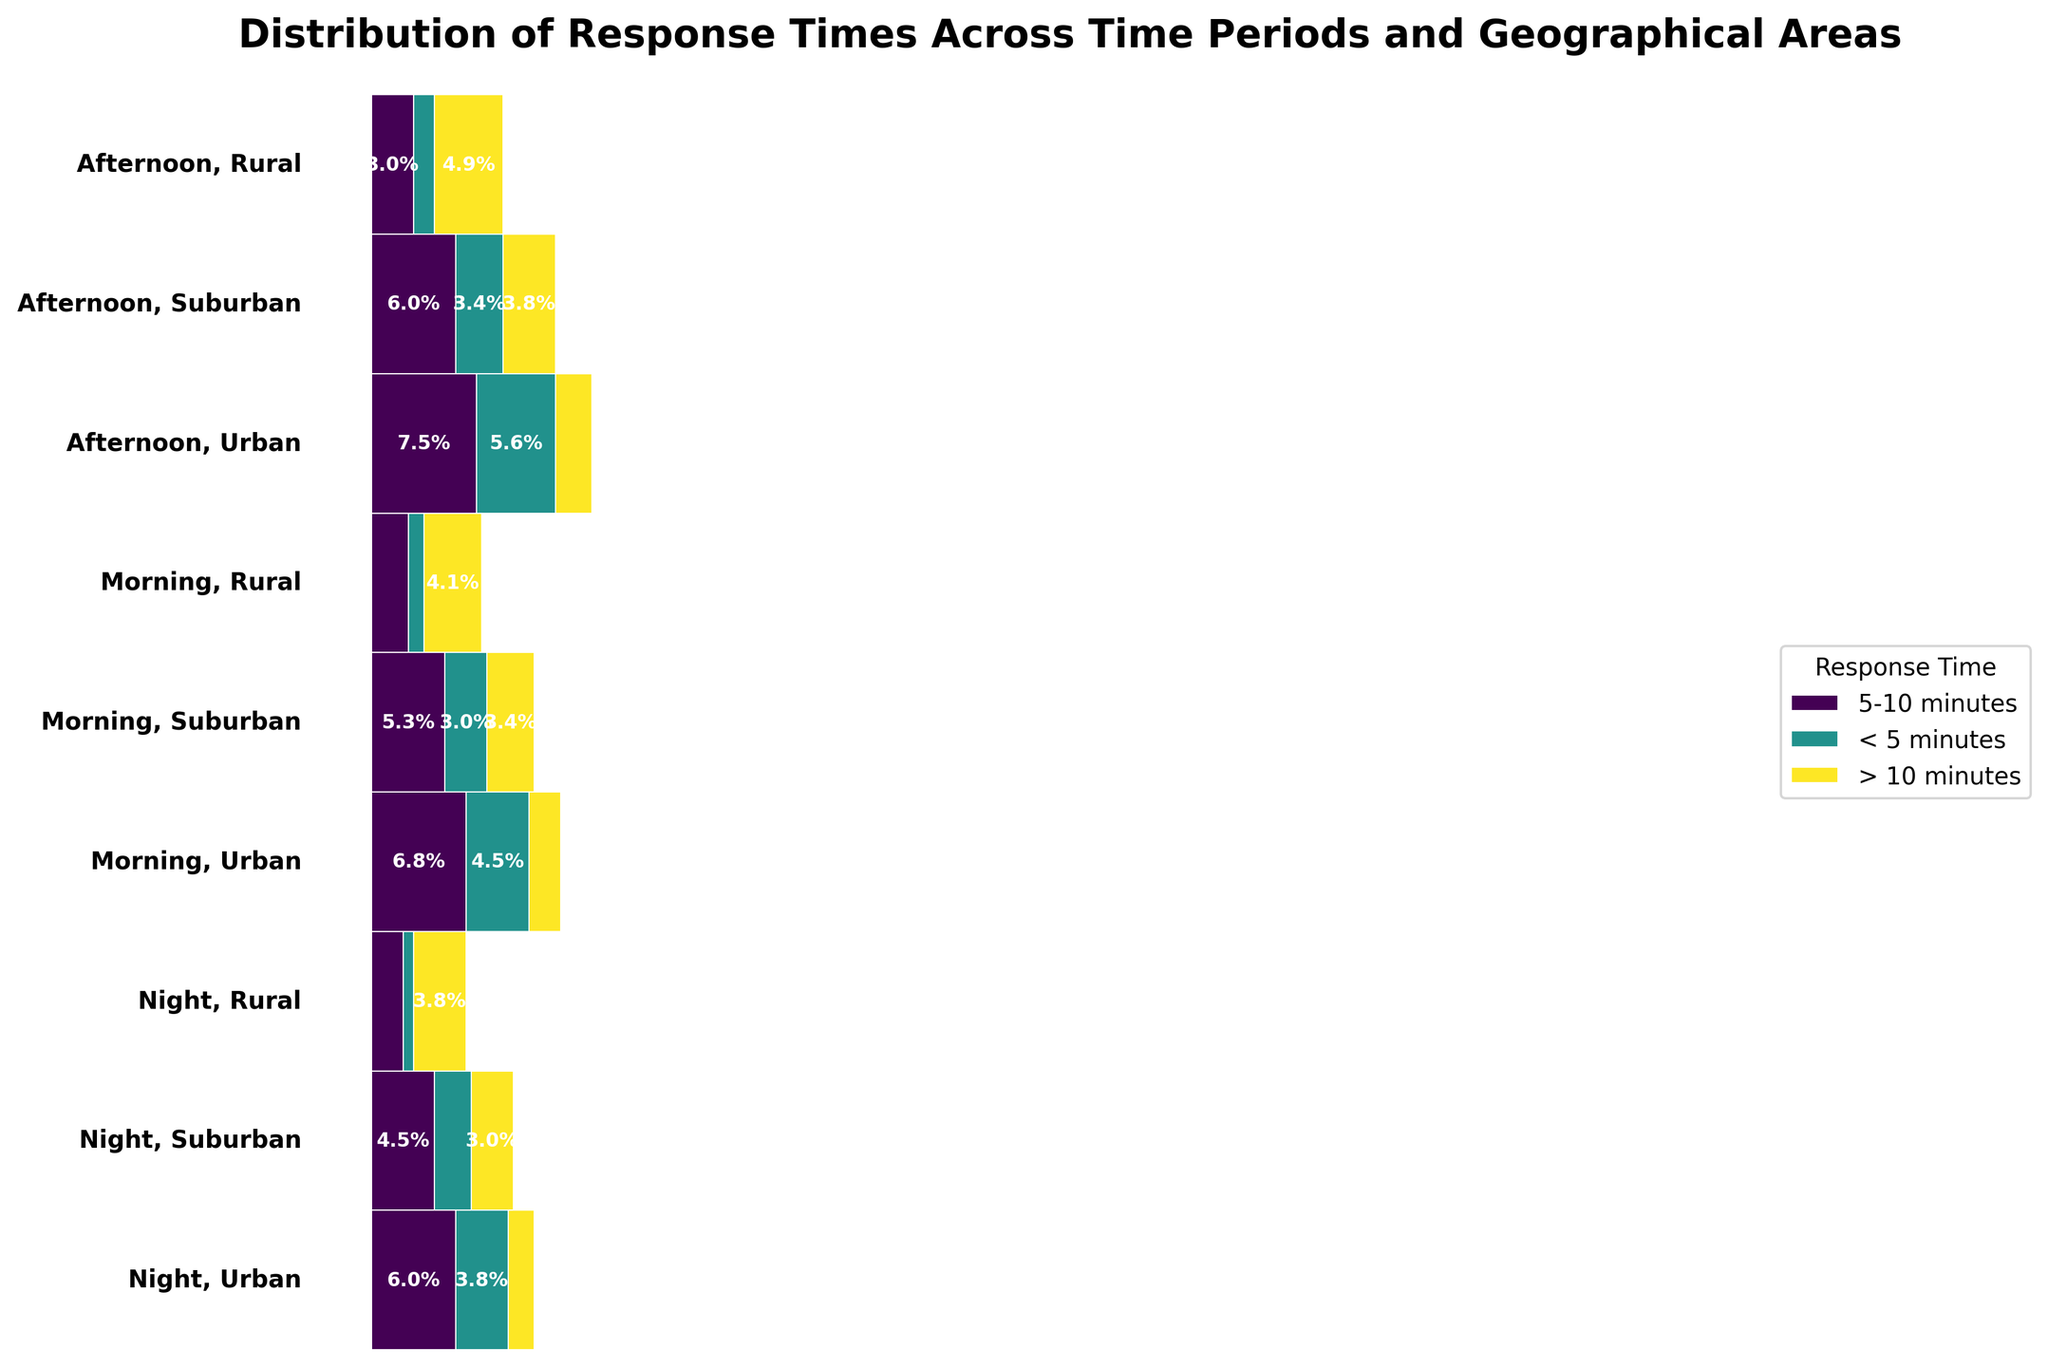What's the title of the figure? The figure title is displayed at the top. It reads "Distribution of Response Times Across Time Periods and Geographical Areas".
Answer: Distribution of Response Times Across Time Periods and Geographical Areas What are the three response times depicted in the legend? The legend on the right side of the figure lists three response times: '< 5 minutes', '5-10 minutes', and '> 10 minutes'.
Answer: '< 5 minutes', '5-10 minutes', '> 10 minutes' Which time period and geographical area combination has the highest proportion of response times greater than 10 minutes? To find this, look for the longest segment colored for '> 10 minutes'. The darkest segment for '> 10 minutes' appears in 'Afternoon, Rural'.
Answer: Afternoon, Rural What is the combined percentage of calls with response times less than 5 minutes in Urban areas across all time periods? First, find the proportions of '< 5 minutes' in Urban areas for each time period and then sum them up. Morning: 120/(120+180+60) = 0.2857, Afternoon: 150/(150+200+70) = 0.3333, Night: 100/(100+160+50) = 0.3333. Combined percentage: (0.2857 + 0.3333 + 0.3333) = 0.9523.
Answer: 95.23% How does the distribution of response times in Suburban areas at night compare to those in the morning? Compare proportion sizes of each response time category between 'Night, Suburban' and 'Morning, Suburban'. Night has fewer <5 min and >10 min calls but slightly more 5-10 min calls than the morning.
Answer: Night has fewer < 5 and > 10 min calls than Morning In which geographical area and time period is the proportion of 5-10 minute response times the smallest? Look for the segment representing '5-10 minutes' that is the smallest proportionally across various areas and times. The smallest proportion appears at 'Morning, Rural'.
Answer: Morning, Rural Which time period, overall, has the largest proportion of calls with response times greater than 10 minutes? Compare the total width of '> 10 minutes' segments across all geographical areas within each time period. The Afternoon period has the largest proportion.
Answer: Afternoon What is the proportion of response times less than 5 minutes for Rural areas in the Afternoon? Identify the '< 5 minutes' segment in 'Afternoon, Rural', and read its proportion.
Answer: 0.16 or 16% Compare the response times of Urban and Suburban areas during the Morning. Look at the segment proportions for '< 5 minutes', '5-10 minutes', and '> 10 minutes' in Urban and Suburban areas during the Morning. Urban areas have a higher proportion of < 5 min responses, while Suburban areas surpass in > 10 min responses.
Answer: Urban has higher < 5 min response, Suburban has higher > 10 min response 